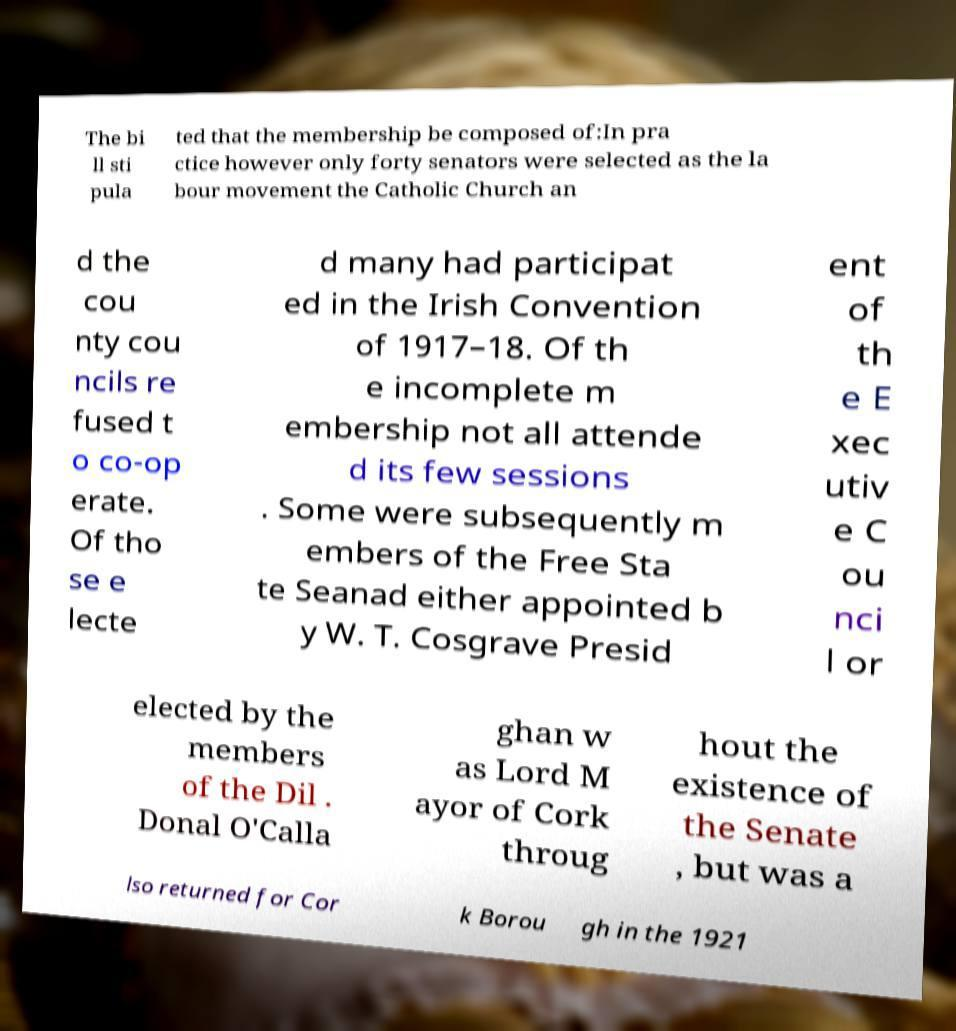Can you read and provide the text displayed in the image?This photo seems to have some interesting text. Can you extract and type it out for me? The bi ll sti pula ted that the membership be composed of:In pra ctice however only forty senators were selected as the la bour movement the Catholic Church an d the cou nty cou ncils re fused t o co-op erate. Of tho se e lecte d many had participat ed in the Irish Convention of 1917–18. Of th e incomplete m embership not all attende d its few sessions . Some were subsequently m embers of the Free Sta te Seanad either appointed b y W. T. Cosgrave Presid ent of th e E xec utiv e C ou nci l or elected by the members of the Dil . Donal O'Calla ghan w as Lord M ayor of Cork throug hout the existence of the Senate , but was a lso returned for Cor k Borou gh in the 1921 